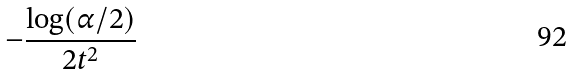<formula> <loc_0><loc_0><loc_500><loc_500>- \frac { \log ( \alpha / 2 ) } { 2 t ^ { 2 } }</formula> 